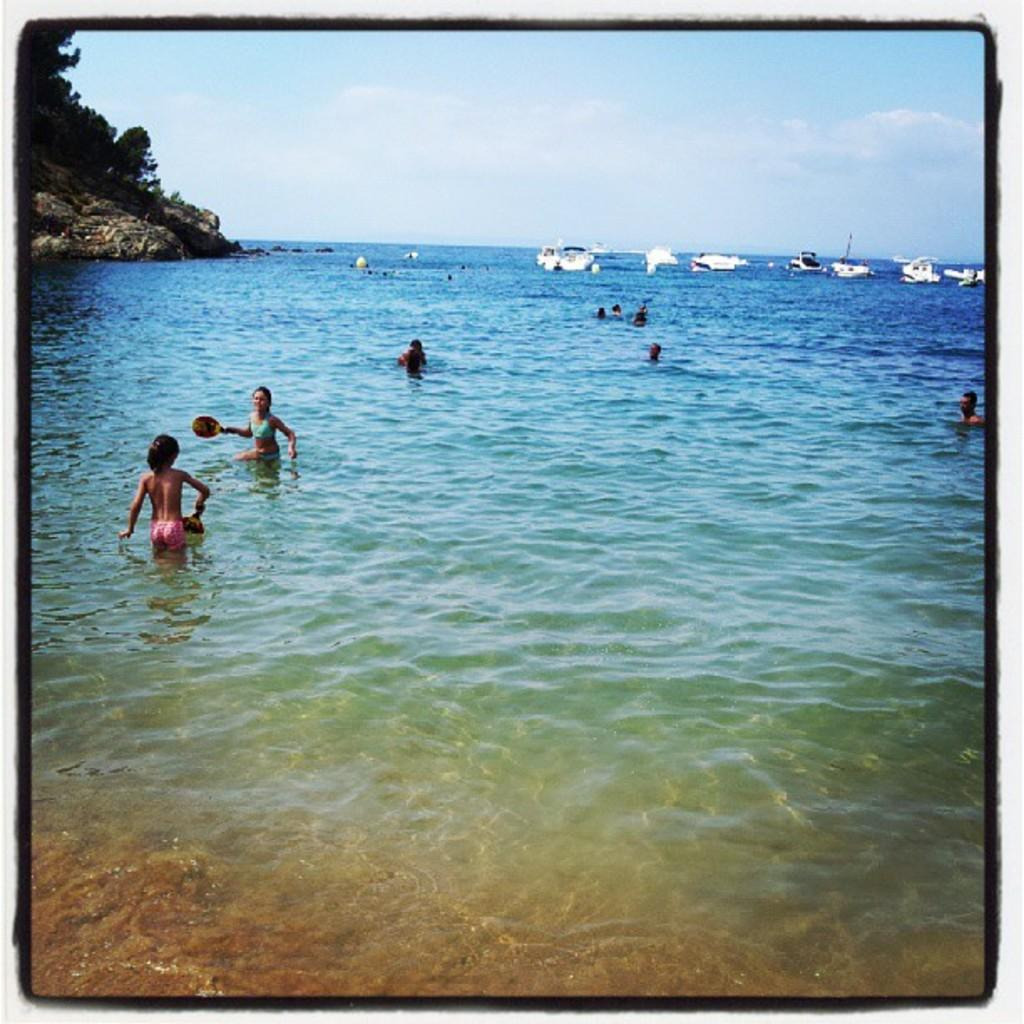What are the people in the image doing? The people in the image are swimming. Where is the swimming taking place? The swimming is taking place at a beach. What can be seen in the background of the image? There are boats in the ocean in the background of the image. What is located on the left side of the image? There is a hill on the left side of the image. What is visible above the hill? The sky is visible above the hill. What word is being spelled out by the people on the street in the image? There is no street or people spelling out a word in the image; it features people swimming at a beach with boats in the background, a hill on the left side, and the sky visible above it. 